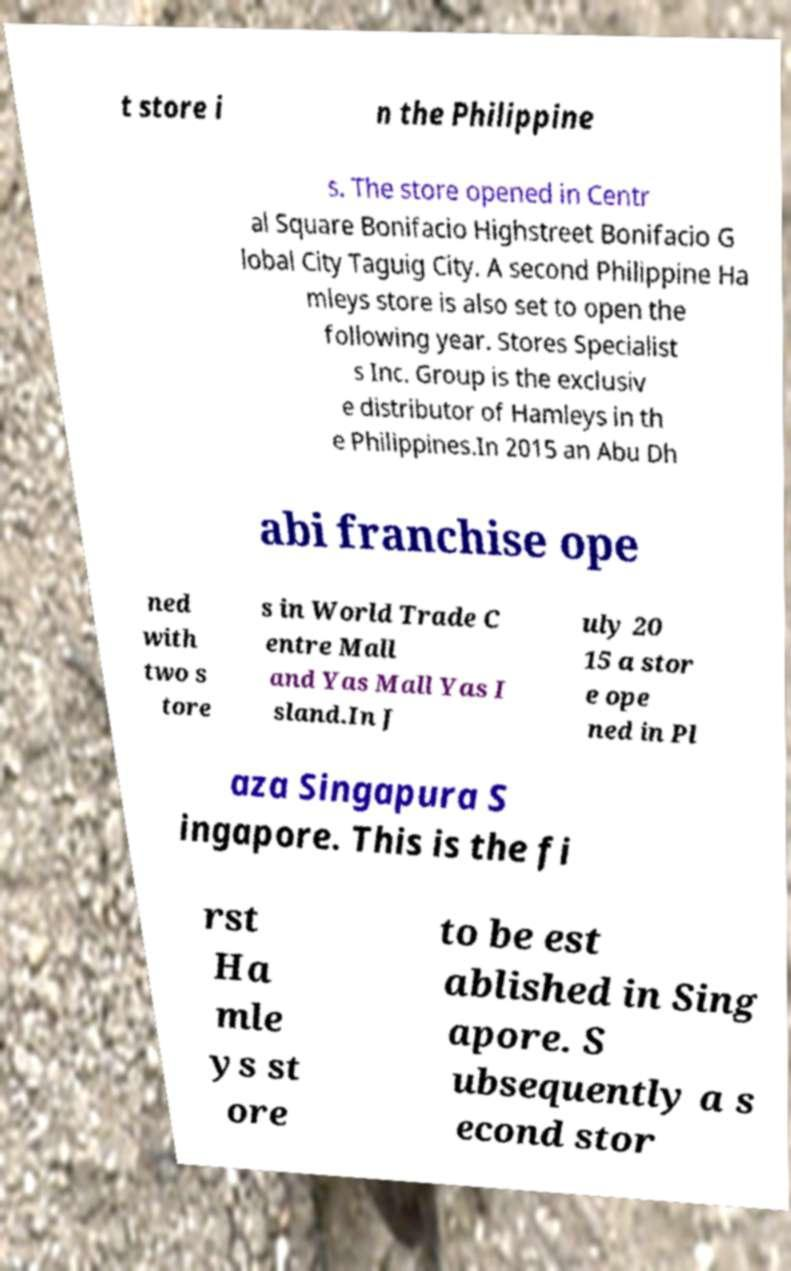Can you accurately transcribe the text from the provided image for me? t store i n the Philippine s. The store opened in Centr al Square Bonifacio Highstreet Bonifacio G lobal City Taguig City. A second Philippine Ha mleys store is also set to open the following year. Stores Specialist s Inc. Group is the exclusiv e distributor of Hamleys in th e Philippines.In 2015 an Abu Dh abi franchise ope ned with two s tore s in World Trade C entre Mall and Yas Mall Yas I sland.In J uly 20 15 a stor e ope ned in Pl aza Singapura S ingapore. This is the fi rst Ha mle ys st ore to be est ablished in Sing apore. S ubsequently a s econd stor 